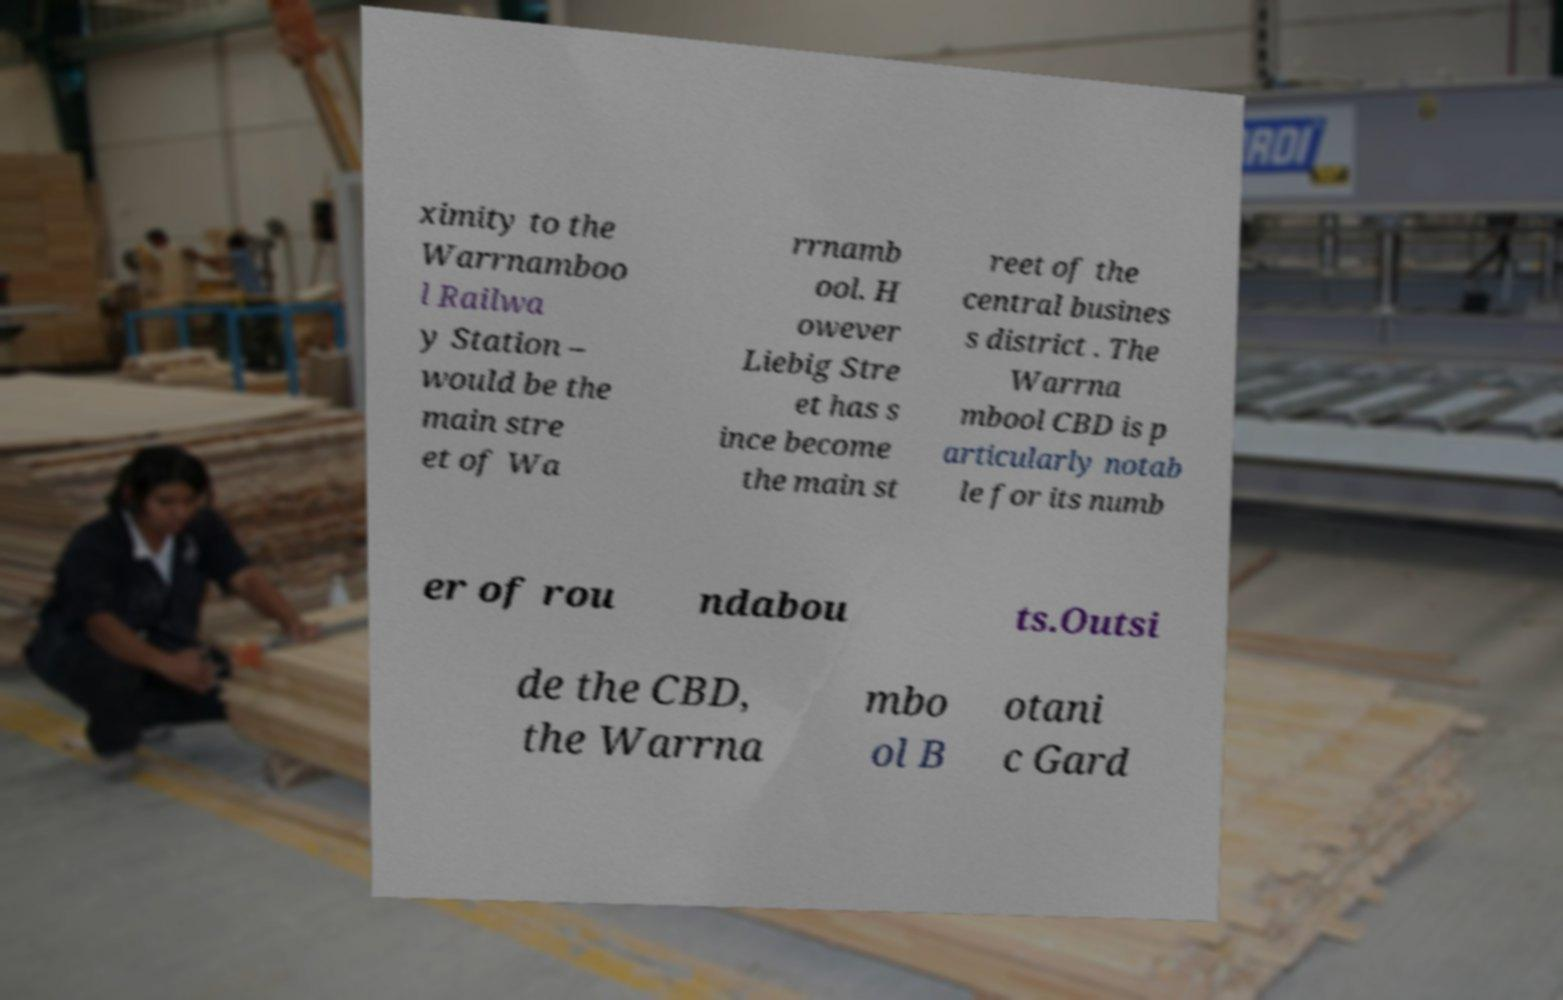What messages or text are displayed in this image? I need them in a readable, typed format. ximity to the Warrnamboo l Railwa y Station – would be the main stre et of Wa rrnamb ool. H owever Liebig Stre et has s ince become the main st reet of the central busines s district . The Warrna mbool CBD is p articularly notab le for its numb er of rou ndabou ts.Outsi de the CBD, the Warrna mbo ol B otani c Gard 